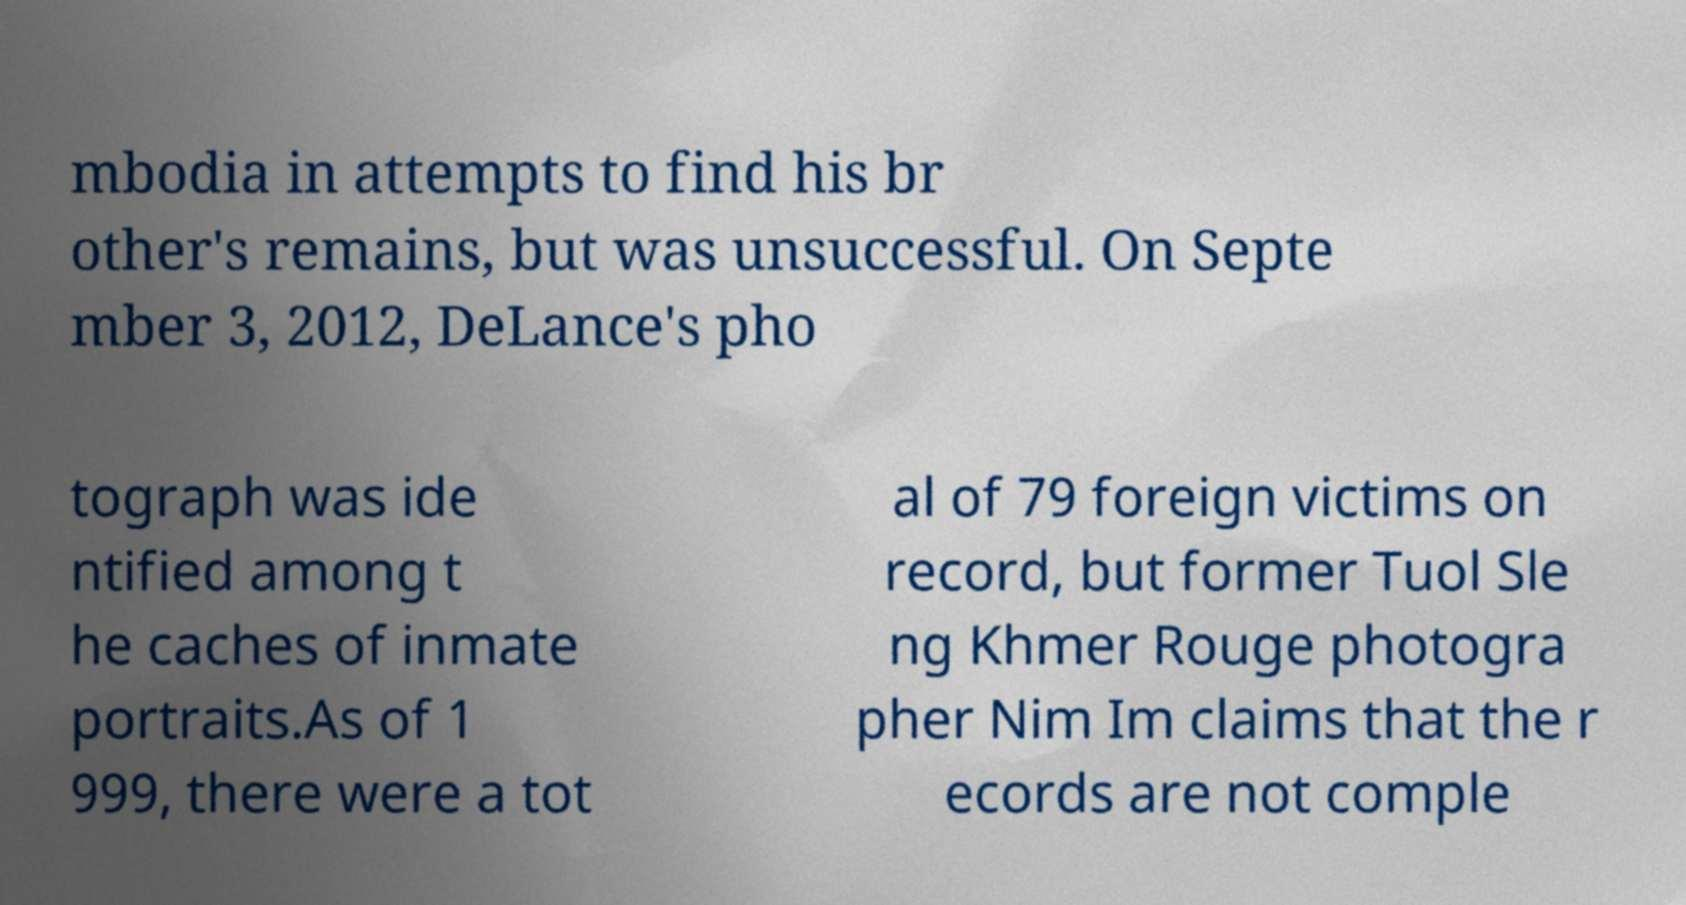Could you assist in decoding the text presented in this image and type it out clearly? mbodia in attempts to find his br other's remains, but was unsuccessful. On Septe mber 3, 2012, DeLance's pho tograph was ide ntified among t he caches of inmate portraits.As of 1 999, there were a tot al of 79 foreign victims on record, but former Tuol Sle ng Khmer Rouge photogra pher Nim Im claims that the r ecords are not comple 